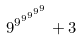Convert formula to latex. <formula><loc_0><loc_0><loc_500><loc_500>9 ^ { 9 ^ { 9 ^ { 9 ^ { 9 ^ { 9 } } } } } + 3</formula> 